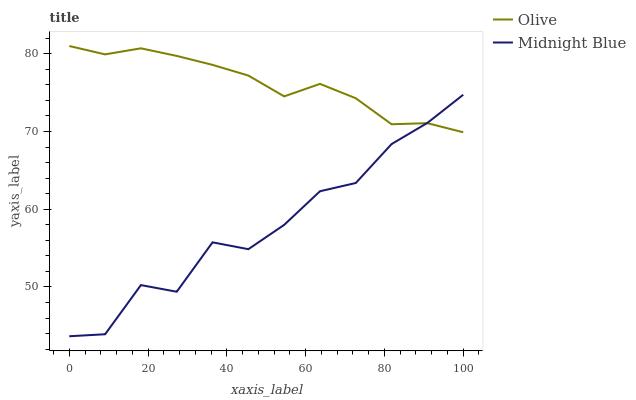Does Midnight Blue have the minimum area under the curve?
Answer yes or no. Yes. Does Olive have the maximum area under the curve?
Answer yes or no. Yes. Does Midnight Blue have the maximum area under the curve?
Answer yes or no. No. Is Olive the smoothest?
Answer yes or no. Yes. Is Midnight Blue the roughest?
Answer yes or no. Yes. Is Midnight Blue the smoothest?
Answer yes or no. No. Does Midnight Blue have the lowest value?
Answer yes or no. Yes. Does Olive have the highest value?
Answer yes or no. Yes. Does Midnight Blue have the highest value?
Answer yes or no. No. Does Olive intersect Midnight Blue?
Answer yes or no. Yes. Is Olive less than Midnight Blue?
Answer yes or no. No. Is Olive greater than Midnight Blue?
Answer yes or no. No. 